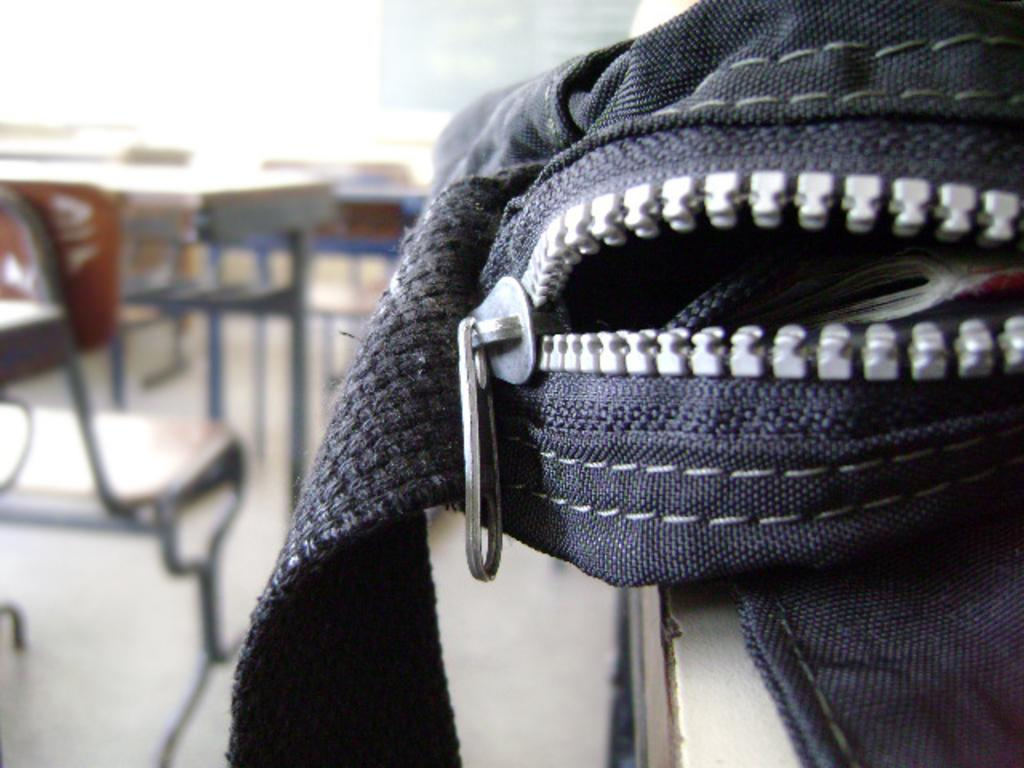What is the main subject of the image? The main subject of the image is a bag. Can you describe the setting in which the bag is located? In the background of the image, there are chairs, tables, a wall, and a board. What type of furniture can be seen in the background? Chairs and tables are visible in the background of the image. What is the purpose of the board in the background? The purpose of the board is not specified in the image, but it could be used for displaying information or announcements. Can you see any agreements being signed on the board in the image? There is no indication of any agreements being signed on the board in the image. Is there a snake visible in the image? There is no snake present in the image. 